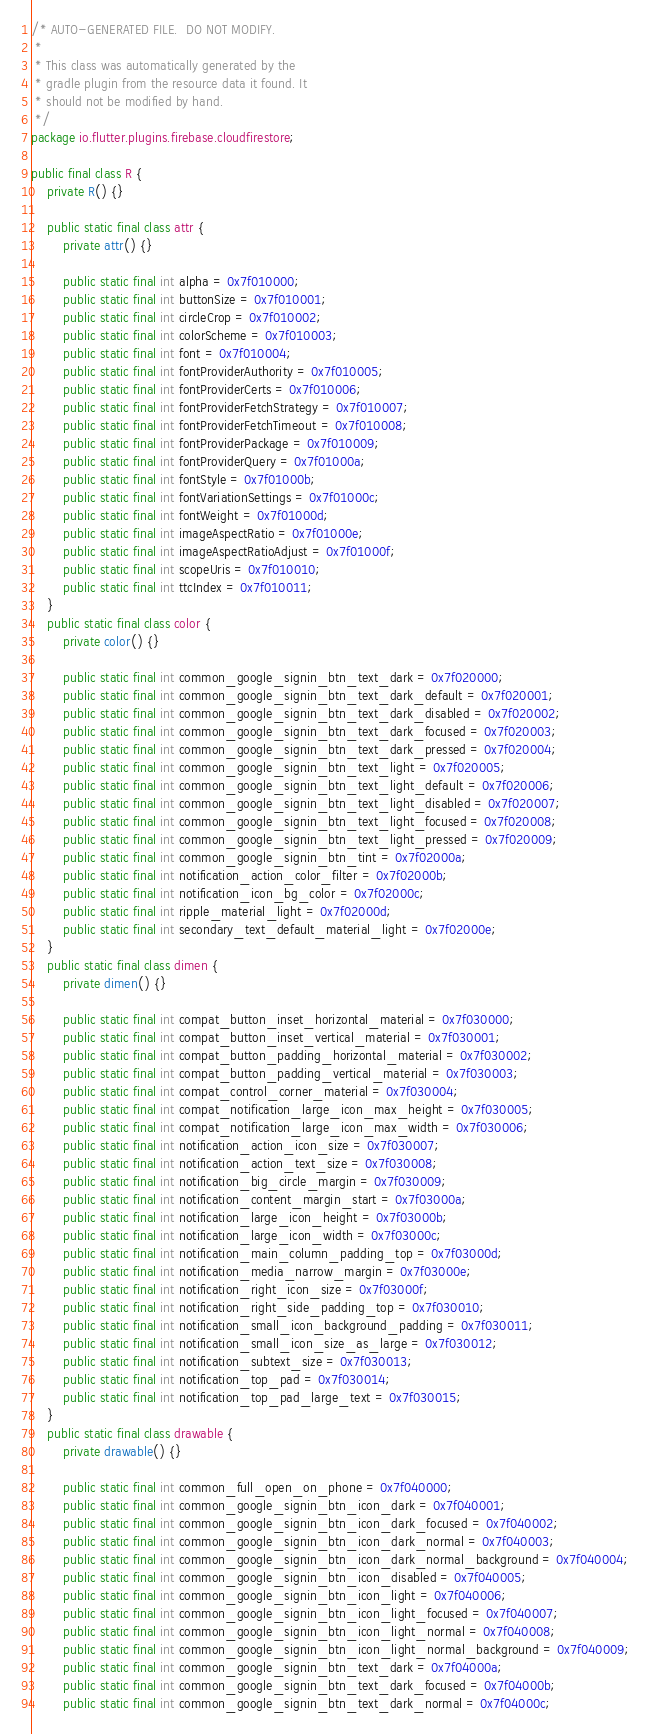<code> <loc_0><loc_0><loc_500><loc_500><_Java_>/* AUTO-GENERATED FILE.  DO NOT MODIFY.
 *
 * This class was automatically generated by the
 * gradle plugin from the resource data it found. It
 * should not be modified by hand.
 */
package io.flutter.plugins.firebase.cloudfirestore;

public final class R {
    private R() {}

    public static final class attr {
        private attr() {}

        public static final int alpha = 0x7f010000;
        public static final int buttonSize = 0x7f010001;
        public static final int circleCrop = 0x7f010002;
        public static final int colorScheme = 0x7f010003;
        public static final int font = 0x7f010004;
        public static final int fontProviderAuthority = 0x7f010005;
        public static final int fontProviderCerts = 0x7f010006;
        public static final int fontProviderFetchStrategy = 0x7f010007;
        public static final int fontProviderFetchTimeout = 0x7f010008;
        public static final int fontProviderPackage = 0x7f010009;
        public static final int fontProviderQuery = 0x7f01000a;
        public static final int fontStyle = 0x7f01000b;
        public static final int fontVariationSettings = 0x7f01000c;
        public static final int fontWeight = 0x7f01000d;
        public static final int imageAspectRatio = 0x7f01000e;
        public static final int imageAspectRatioAdjust = 0x7f01000f;
        public static final int scopeUris = 0x7f010010;
        public static final int ttcIndex = 0x7f010011;
    }
    public static final class color {
        private color() {}

        public static final int common_google_signin_btn_text_dark = 0x7f020000;
        public static final int common_google_signin_btn_text_dark_default = 0x7f020001;
        public static final int common_google_signin_btn_text_dark_disabled = 0x7f020002;
        public static final int common_google_signin_btn_text_dark_focused = 0x7f020003;
        public static final int common_google_signin_btn_text_dark_pressed = 0x7f020004;
        public static final int common_google_signin_btn_text_light = 0x7f020005;
        public static final int common_google_signin_btn_text_light_default = 0x7f020006;
        public static final int common_google_signin_btn_text_light_disabled = 0x7f020007;
        public static final int common_google_signin_btn_text_light_focused = 0x7f020008;
        public static final int common_google_signin_btn_text_light_pressed = 0x7f020009;
        public static final int common_google_signin_btn_tint = 0x7f02000a;
        public static final int notification_action_color_filter = 0x7f02000b;
        public static final int notification_icon_bg_color = 0x7f02000c;
        public static final int ripple_material_light = 0x7f02000d;
        public static final int secondary_text_default_material_light = 0x7f02000e;
    }
    public static final class dimen {
        private dimen() {}

        public static final int compat_button_inset_horizontal_material = 0x7f030000;
        public static final int compat_button_inset_vertical_material = 0x7f030001;
        public static final int compat_button_padding_horizontal_material = 0x7f030002;
        public static final int compat_button_padding_vertical_material = 0x7f030003;
        public static final int compat_control_corner_material = 0x7f030004;
        public static final int compat_notification_large_icon_max_height = 0x7f030005;
        public static final int compat_notification_large_icon_max_width = 0x7f030006;
        public static final int notification_action_icon_size = 0x7f030007;
        public static final int notification_action_text_size = 0x7f030008;
        public static final int notification_big_circle_margin = 0x7f030009;
        public static final int notification_content_margin_start = 0x7f03000a;
        public static final int notification_large_icon_height = 0x7f03000b;
        public static final int notification_large_icon_width = 0x7f03000c;
        public static final int notification_main_column_padding_top = 0x7f03000d;
        public static final int notification_media_narrow_margin = 0x7f03000e;
        public static final int notification_right_icon_size = 0x7f03000f;
        public static final int notification_right_side_padding_top = 0x7f030010;
        public static final int notification_small_icon_background_padding = 0x7f030011;
        public static final int notification_small_icon_size_as_large = 0x7f030012;
        public static final int notification_subtext_size = 0x7f030013;
        public static final int notification_top_pad = 0x7f030014;
        public static final int notification_top_pad_large_text = 0x7f030015;
    }
    public static final class drawable {
        private drawable() {}

        public static final int common_full_open_on_phone = 0x7f040000;
        public static final int common_google_signin_btn_icon_dark = 0x7f040001;
        public static final int common_google_signin_btn_icon_dark_focused = 0x7f040002;
        public static final int common_google_signin_btn_icon_dark_normal = 0x7f040003;
        public static final int common_google_signin_btn_icon_dark_normal_background = 0x7f040004;
        public static final int common_google_signin_btn_icon_disabled = 0x7f040005;
        public static final int common_google_signin_btn_icon_light = 0x7f040006;
        public static final int common_google_signin_btn_icon_light_focused = 0x7f040007;
        public static final int common_google_signin_btn_icon_light_normal = 0x7f040008;
        public static final int common_google_signin_btn_icon_light_normal_background = 0x7f040009;
        public static final int common_google_signin_btn_text_dark = 0x7f04000a;
        public static final int common_google_signin_btn_text_dark_focused = 0x7f04000b;
        public static final int common_google_signin_btn_text_dark_normal = 0x7f04000c;</code> 